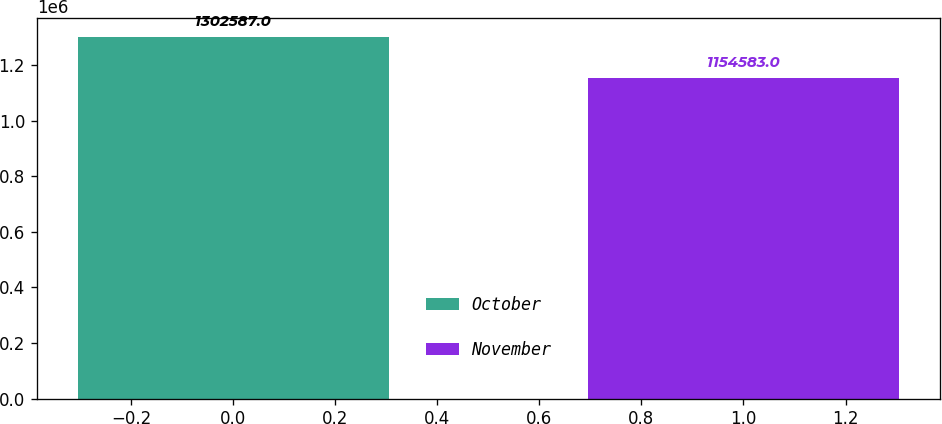<chart> <loc_0><loc_0><loc_500><loc_500><bar_chart><fcel>October<fcel>November<nl><fcel>1.30259e+06<fcel>1.15458e+06<nl></chart> 